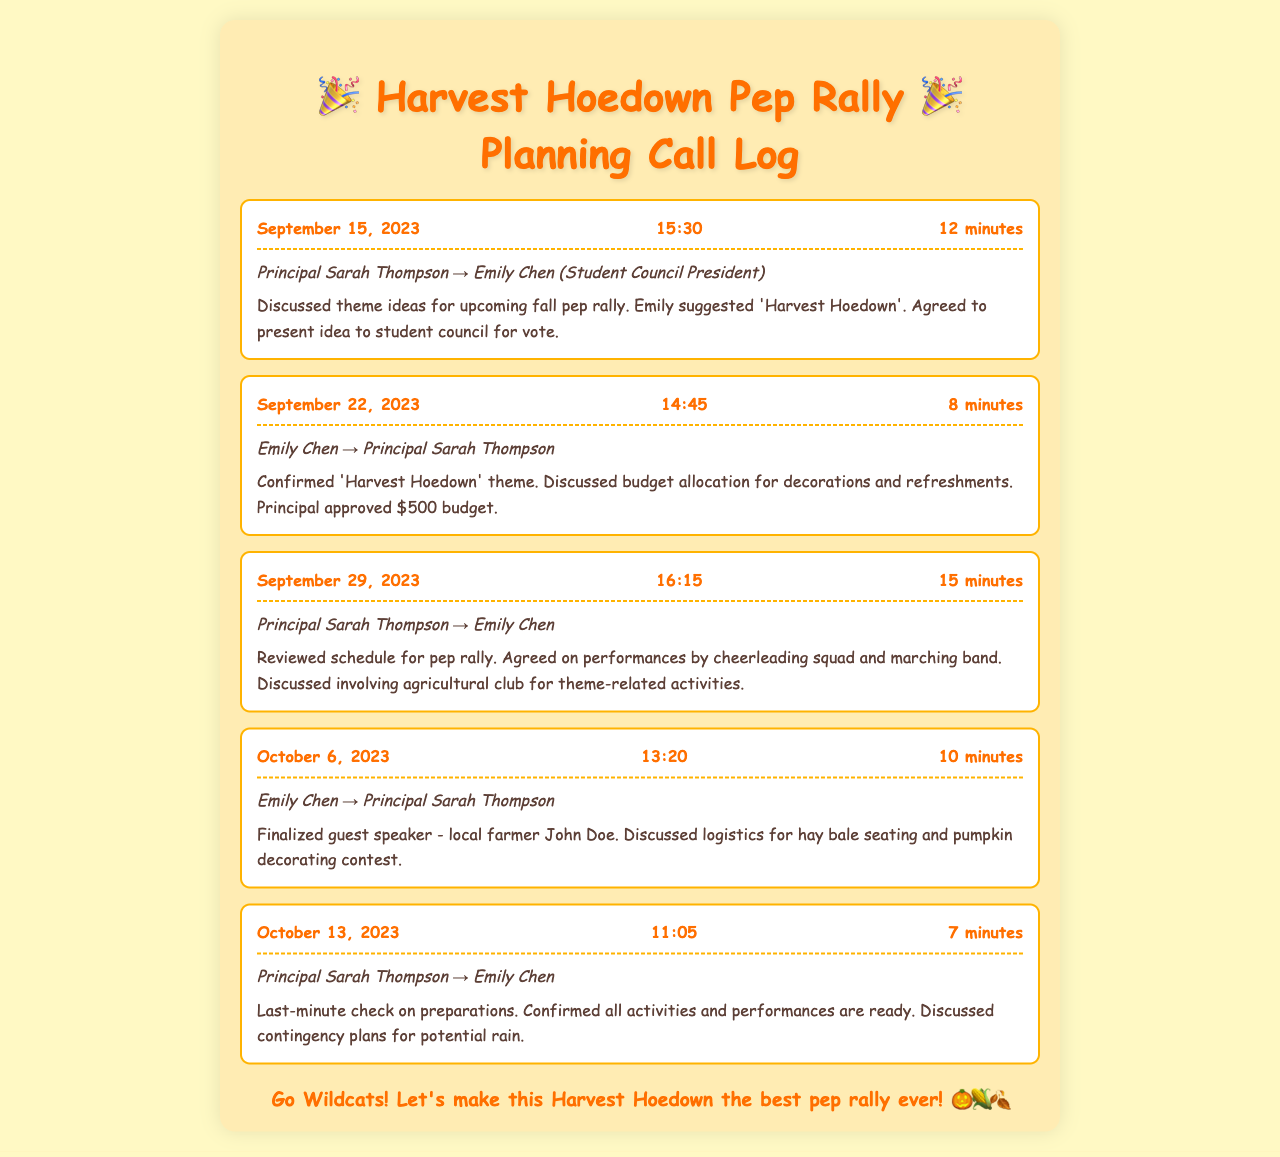What is the theme for the pep rally? The theme 'Harvest Hoedown' was suggested by Emily Chen during a call on September 15, 2023.
Answer: Harvest Hoedown Who approved the budget for decorations? The budget was approved by Principal Sarah Thompson during a call on September 22, 2023.
Answer: Principal Sarah Thompson What was the date of the call where the guest speaker was finalized? The call on October 6, 2023, involved discussing and finalizing the guest speaker.
Answer: October 6, 2023 How long was the call on September 29, 2023? The duration of the call was 15 minutes, as recorded in the call summary.
Answer: 15 minutes Which activities were agreed to involve the agricultural club? The discussions during the call on September 29, 2023, included involving the agricultural club for theme-related activities.
Answer: Theme-related activities What contingency plans were discussed during the last-minute check? The discussion on October 13, 2023, included preparing for potential rain as a contingency plan.
Answer: Potential rain When was the first discussion about the pep rally? The first discussion occurred on September 15, 2023, regarding theme ideas.
Answer: September 15, 2023 What logistical details were discussed for the pep rally? The logistics for hay bale seating and a pumpkin decorating contest were addressed during a call on October 6, 2023.
Answer: Hay bale seating and pumpkin decorating contest How many minutes was the call on October 13, 2023? The call lasted for 7 minutes as noted in the call duration.
Answer: 7 minutes 